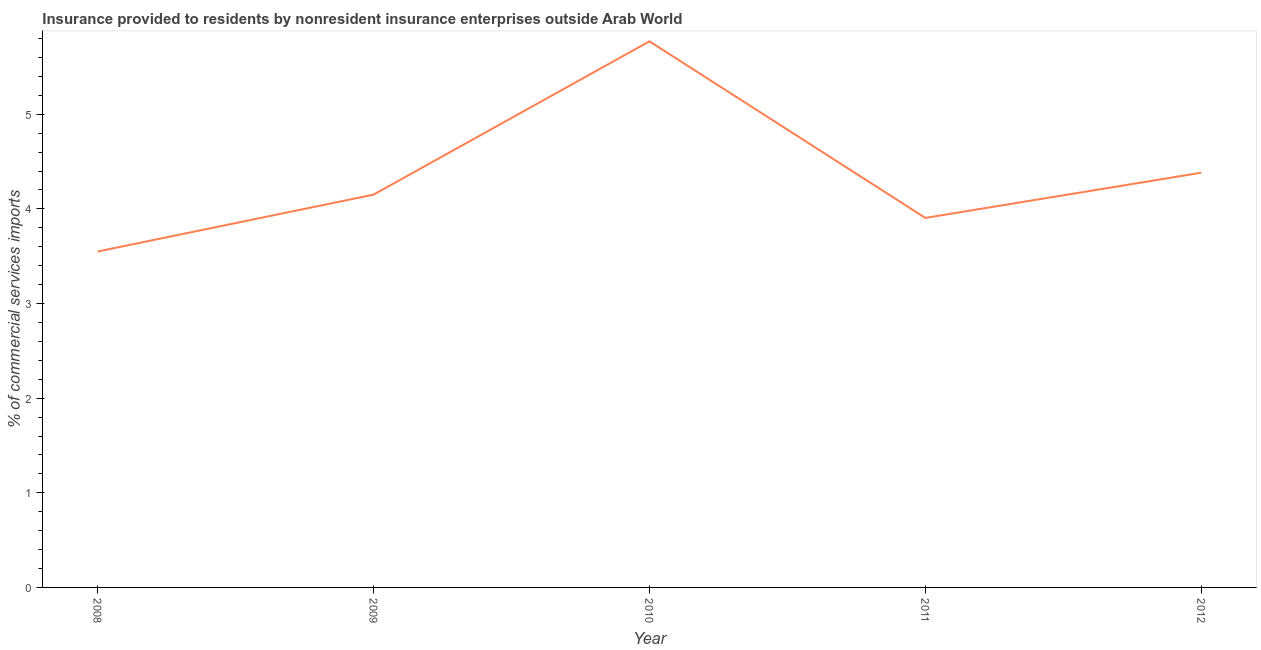What is the insurance provided by non-residents in 2008?
Ensure brevity in your answer.  3.55. Across all years, what is the maximum insurance provided by non-residents?
Offer a terse response. 5.77. Across all years, what is the minimum insurance provided by non-residents?
Provide a short and direct response. 3.55. What is the sum of the insurance provided by non-residents?
Give a very brief answer. 21.76. What is the difference between the insurance provided by non-residents in 2008 and 2011?
Offer a terse response. -0.36. What is the average insurance provided by non-residents per year?
Offer a very short reply. 4.35. What is the median insurance provided by non-residents?
Offer a terse response. 4.15. Do a majority of the years between 2012 and 2008 (inclusive) have insurance provided by non-residents greater than 2.4 %?
Your answer should be compact. Yes. What is the ratio of the insurance provided by non-residents in 2008 to that in 2009?
Keep it short and to the point. 0.86. Is the insurance provided by non-residents in 2008 less than that in 2009?
Give a very brief answer. Yes. What is the difference between the highest and the second highest insurance provided by non-residents?
Your answer should be compact. 1.39. Is the sum of the insurance provided by non-residents in 2010 and 2012 greater than the maximum insurance provided by non-residents across all years?
Give a very brief answer. Yes. What is the difference between the highest and the lowest insurance provided by non-residents?
Offer a very short reply. 2.22. In how many years, is the insurance provided by non-residents greater than the average insurance provided by non-residents taken over all years?
Your answer should be compact. 2. Does the insurance provided by non-residents monotonically increase over the years?
Offer a very short reply. No. How many years are there in the graph?
Keep it short and to the point. 5. Does the graph contain any zero values?
Make the answer very short. No. What is the title of the graph?
Your answer should be compact. Insurance provided to residents by nonresident insurance enterprises outside Arab World. What is the label or title of the X-axis?
Offer a terse response. Year. What is the label or title of the Y-axis?
Keep it short and to the point. % of commercial services imports. What is the % of commercial services imports in 2008?
Give a very brief answer. 3.55. What is the % of commercial services imports in 2009?
Keep it short and to the point. 4.15. What is the % of commercial services imports of 2010?
Offer a terse response. 5.77. What is the % of commercial services imports in 2011?
Ensure brevity in your answer.  3.9. What is the % of commercial services imports of 2012?
Keep it short and to the point. 4.38. What is the difference between the % of commercial services imports in 2008 and 2009?
Provide a succinct answer. -0.6. What is the difference between the % of commercial services imports in 2008 and 2010?
Offer a very short reply. -2.22. What is the difference between the % of commercial services imports in 2008 and 2011?
Give a very brief answer. -0.36. What is the difference between the % of commercial services imports in 2008 and 2012?
Provide a short and direct response. -0.83. What is the difference between the % of commercial services imports in 2009 and 2010?
Your answer should be very brief. -1.62. What is the difference between the % of commercial services imports in 2009 and 2011?
Ensure brevity in your answer.  0.25. What is the difference between the % of commercial services imports in 2009 and 2012?
Ensure brevity in your answer.  -0.23. What is the difference between the % of commercial services imports in 2010 and 2011?
Make the answer very short. 1.87. What is the difference between the % of commercial services imports in 2010 and 2012?
Provide a succinct answer. 1.39. What is the difference between the % of commercial services imports in 2011 and 2012?
Your answer should be compact. -0.48. What is the ratio of the % of commercial services imports in 2008 to that in 2009?
Your answer should be compact. 0.85. What is the ratio of the % of commercial services imports in 2008 to that in 2010?
Offer a terse response. 0.61. What is the ratio of the % of commercial services imports in 2008 to that in 2011?
Your answer should be compact. 0.91. What is the ratio of the % of commercial services imports in 2008 to that in 2012?
Offer a terse response. 0.81. What is the ratio of the % of commercial services imports in 2009 to that in 2010?
Your answer should be very brief. 0.72. What is the ratio of the % of commercial services imports in 2009 to that in 2011?
Provide a succinct answer. 1.06. What is the ratio of the % of commercial services imports in 2009 to that in 2012?
Offer a very short reply. 0.95. What is the ratio of the % of commercial services imports in 2010 to that in 2011?
Ensure brevity in your answer.  1.48. What is the ratio of the % of commercial services imports in 2010 to that in 2012?
Offer a terse response. 1.32. What is the ratio of the % of commercial services imports in 2011 to that in 2012?
Your response must be concise. 0.89. 